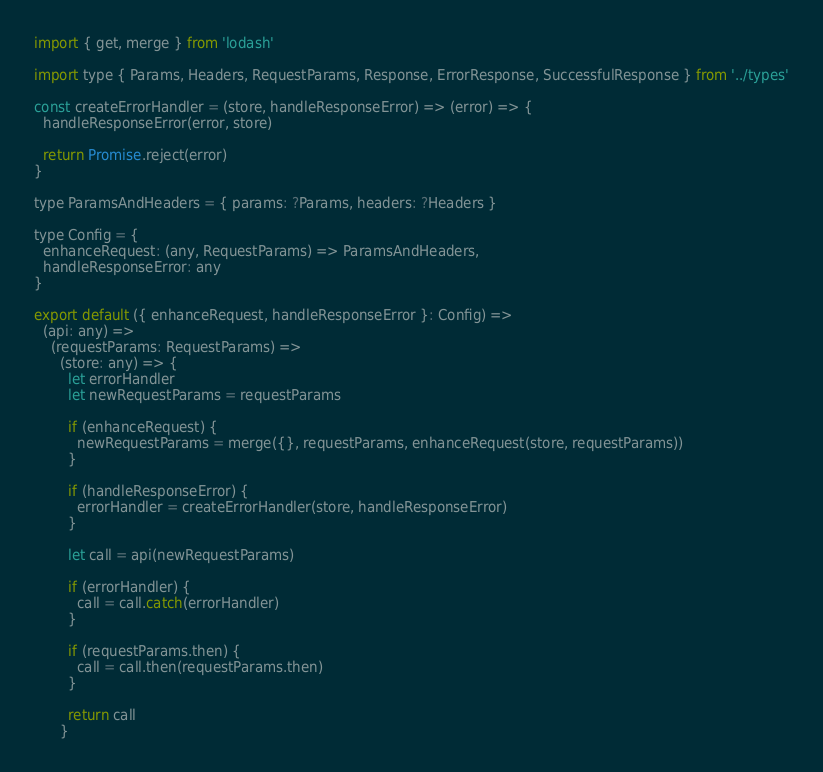Convert code to text. <code><loc_0><loc_0><loc_500><loc_500><_JavaScript_>import { get, merge } from 'lodash'

import type { Params, Headers, RequestParams, Response, ErrorResponse, SuccessfulResponse } from '../types'

const createErrorHandler = (store, handleResponseError) => (error) => {
  handleResponseError(error, store)

  return Promise.reject(error)
}

type ParamsAndHeaders = { params: ?Params, headers: ?Headers }

type Config = {
  enhanceRequest: (any, RequestParams) => ParamsAndHeaders,
  handleResponseError: any
}

export default ({ enhanceRequest, handleResponseError }: Config) =>
  (api: any) =>
    (requestParams: RequestParams) =>
      (store: any) => {
        let errorHandler
        let newRequestParams = requestParams
          
        if (enhanceRequest) {
          newRequestParams = merge({}, requestParams, enhanceRequest(store, requestParams))
        }

        if (handleResponseError) {
          errorHandler = createErrorHandler(store, handleResponseError)
        }

        let call = api(newRequestParams)

        if (errorHandler) {
          call = call.catch(errorHandler)
        }

        if (requestParams.then) {
          call = call.then(requestParams.then)
        }

        return call
      }
</code> 